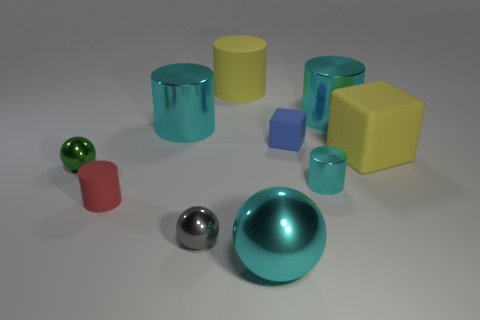What is the color of the rubber cylinder that is the same size as the green shiny ball?
Offer a terse response. Red. The green shiny thing has what size?
Give a very brief answer. Small. Do the large cylinder on the right side of the tiny cyan shiny thing and the tiny blue thing have the same material?
Your answer should be compact. No. Does the small cyan shiny thing have the same shape as the tiny red object?
Offer a terse response. Yes. There is a cyan metal thing that is in front of the tiny ball that is right of the big cyan metal cylinder that is left of the large yellow cylinder; what is its shape?
Offer a very short reply. Sphere. There is a yellow rubber object to the right of the big metal sphere; does it have the same shape as the yellow rubber object that is behind the blue object?
Make the answer very short. No. Is there a small red thing made of the same material as the big yellow cylinder?
Ensure brevity in your answer.  Yes. There is a rubber cylinder that is in front of the large rubber cylinder on the right side of the small metal object in front of the tiny red cylinder; what color is it?
Your answer should be compact. Red. Do the cube that is in front of the tiny blue object and the tiny cylinder that is to the left of the tiny cube have the same material?
Ensure brevity in your answer.  Yes. There is a large cyan object that is in front of the green sphere; what is its shape?
Your response must be concise. Sphere. 